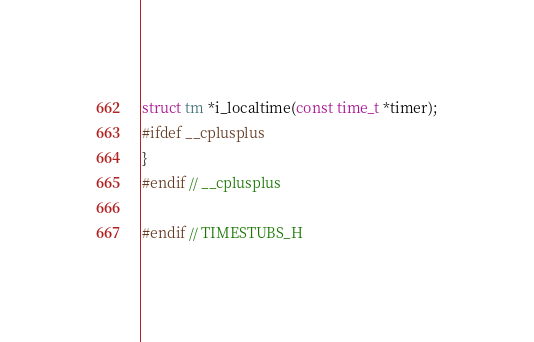Convert code to text. <code><loc_0><loc_0><loc_500><loc_500><_C_>struct tm *i_localtime(const time_t *timer);
#ifdef __cplusplus
}
#endif // __cplusplus

#endif // TIMESTUBS_H
</code> 